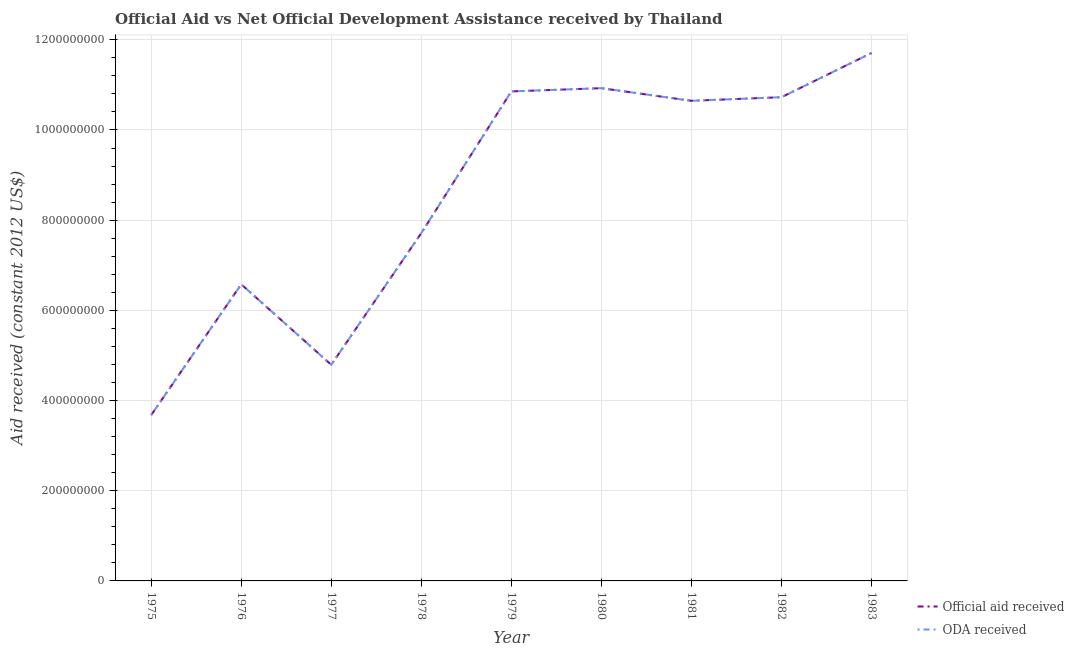Does the line corresponding to official aid received intersect with the line corresponding to oda received?
Provide a succinct answer. Yes. Is the number of lines equal to the number of legend labels?
Provide a succinct answer. Yes. What is the official aid received in 1975?
Offer a very short reply. 3.68e+08. Across all years, what is the maximum official aid received?
Your answer should be very brief. 1.17e+09. Across all years, what is the minimum official aid received?
Your answer should be compact. 3.68e+08. In which year was the official aid received minimum?
Give a very brief answer. 1975. What is the total oda received in the graph?
Provide a succinct answer. 7.76e+09. What is the difference between the official aid received in 1976 and that in 1983?
Your answer should be compact. -5.13e+08. What is the difference between the official aid received in 1975 and the oda received in 1983?
Provide a short and direct response. -8.03e+08. What is the average oda received per year?
Your answer should be compact. 8.63e+08. What is the ratio of the oda received in 1981 to that in 1982?
Offer a very short reply. 0.99. What is the difference between the highest and the second highest official aid received?
Your answer should be compact. 7.81e+07. What is the difference between the highest and the lowest official aid received?
Offer a terse response. 8.03e+08. In how many years, is the oda received greater than the average oda received taken over all years?
Your response must be concise. 5. Does the official aid received monotonically increase over the years?
Provide a short and direct response. No. Is the official aid received strictly less than the oda received over the years?
Make the answer very short. No. How many lines are there?
Provide a short and direct response. 2. How many legend labels are there?
Your answer should be very brief. 2. What is the title of the graph?
Keep it short and to the point. Official Aid vs Net Official Development Assistance received by Thailand . Does "Non-residents" appear as one of the legend labels in the graph?
Your response must be concise. No. What is the label or title of the Y-axis?
Provide a short and direct response. Aid received (constant 2012 US$). What is the Aid received (constant 2012 US$) in Official aid received in 1975?
Make the answer very short. 3.68e+08. What is the Aid received (constant 2012 US$) in ODA received in 1975?
Provide a short and direct response. 3.68e+08. What is the Aid received (constant 2012 US$) in Official aid received in 1976?
Provide a succinct answer. 6.58e+08. What is the Aid received (constant 2012 US$) in ODA received in 1976?
Provide a succinct answer. 6.58e+08. What is the Aid received (constant 2012 US$) in Official aid received in 1977?
Offer a terse response. 4.79e+08. What is the Aid received (constant 2012 US$) in ODA received in 1977?
Your response must be concise. 4.79e+08. What is the Aid received (constant 2012 US$) in Official aid received in 1978?
Your response must be concise. 7.71e+08. What is the Aid received (constant 2012 US$) in ODA received in 1978?
Offer a terse response. 7.71e+08. What is the Aid received (constant 2012 US$) in Official aid received in 1979?
Keep it short and to the point. 1.09e+09. What is the Aid received (constant 2012 US$) in ODA received in 1979?
Keep it short and to the point. 1.09e+09. What is the Aid received (constant 2012 US$) in Official aid received in 1980?
Make the answer very short. 1.09e+09. What is the Aid received (constant 2012 US$) in ODA received in 1980?
Your answer should be very brief. 1.09e+09. What is the Aid received (constant 2012 US$) in Official aid received in 1981?
Offer a terse response. 1.06e+09. What is the Aid received (constant 2012 US$) in ODA received in 1981?
Provide a succinct answer. 1.06e+09. What is the Aid received (constant 2012 US$) of Official aid received in 1982?
Your answer should be compact. 1.07e+09. What is the Aid received (constant 2012 US$) in ODA received in 1982?
Offer a terse response. 1.07e+09. What is the Aid received (constant 2012 US$) in Official aid received in 1983?
Give a very brief answer. 1.17e+09. What is the Aid received (constant 2012 US$) in ODA received in 1983?
Offer a very short reply. 1.17e+09. Across all years, what is the maximum Aid received (constant 2012 US$) in Official aid received?
Your answer should be compact. 1.17e+09. Across all years, what is the maximum Aid received (constant 2012 US$) in ODA received?
Your answer should be compact. 1.17e+09. Across all years, what is the minimum Aid received (constant 2012 US$) in Official aid received?
Provide a short and direct response. 3.68e+08. Across all years, what is the minimum Aid received (constant 2012 US$) of ODA received?
Keep it short and to the point. 3.68e+08. What is the total Aid received (constant 2012 US$) in Official aid received in the graph?
Provide a short and direct response. 7.76e+09. What is the total Aid received (constant 2012 US$) of ODA received in the graph?
Ensure brevity in your answer.  7.76e+09. What is the difference between the Aid received (constant 2012 US$) of Official aid received in 1975 and that in 1976?
Ensure brevity in your answer.  -2.90e+08. What is the difference between the Aid received (constant 2012 US$) of ODA received in 1975 and that in 1976?
Offer a terse response. -2.90e+08. What is the difference between the Aid received (constant 2012 US$) of Official aid received in 1975 and that in 1977?
Your response must be concise. -1.12e+08. What is the difference between the Aid received (constant 2012 US$) of ODA received in 1975 and that in 1977?
Offer a very short reply. -1.12e+08. What is the difference between the Aid received (constant 2012 US$) in Official aid received in 1975 and that in 1978?
Offer a terse response. -4.04e+08. What is the difference between the Aid received (constant 2012 US$) of ODA received in 1975 and that in 1978?
Ensure brevity in your answer.  -4.04e+08. What is the difference between the Aid received (constant 2012 US$) in Official aid received in 1975 and that in 1979?
Offer a very short reply. -7.18e+08. What is the difference between the Aid received (constant 2012 US$) of ODA received in 1975 and that in 1979?
Make the answer very short. -7.18e+08. What is the difference between the Aid received (constant 2012 US$) in Official aid received in 1975 and that in 1980?
Your answer should be very brief. -7.25e+08. What is the difference between the Aid received (constant 2012 US$) of ODA received in 1975 and that in 1980?
Provide a succinct answer. -7.25e+08. What is the difference between the Aid received (constant 2012 US$) in Official aid received in 1975 and that in 1981?
Offer a very short reply. -6.97e+08. What is the difference between the Aid received (constant 2012 US$) of ODA received in 1975 and that in 1981?
Keep it short and to the point. -6.97e+08. What is the difference between the Aid received (constant 2012 US$) of Official aid received in 1975 and that in 1982?
Offer a very short reply. -7.05e+08. What is the difference between the Aid received (constant 2012 US$) of ODA received in 1975 and that in 1982?
Your answer should be compact. -7.05e+08. What is the difference between the Aid received (constant 2012 US$) of Official aid received in 1975 and that in 1983?
Offer a very short reply. -8.03e+08. What is the difference between the Aid received (constant 2012 US$) in ODA received in 1975 and that in 1983?
Give a very brief answer. -8.03e+08. What is the difference between the Aid received (constant 2012 US$) of Official aid received in 1976 and that in 1977?
Make the answer very short. 1.79e+08. What is the difference between the Aid received (constant 2012 US$) in ODA received in 1976 and that in 1977?
Provide a succinct answer. 1.79e+08. What is the difference between the Aid received (constant 2012 US$) in Official aid received in 1976 and that in 1978?
Give a very brief answer. -1.14e+08. What is the difference between the Aid received (constant 2012 US$) in ODA received in 1976 and that in 1978?
Ensure brevity in your answer.  -1.14e+08. What is the difference between the Aid received (constant 2012 US$) of Official aid received in 1976 and that in 1979?
Offer a very short reply. -4.28e+08. What is the difference between the Aid received (constant 2012 US$) of ODA received in 1976 and that in 1979?
Your answer should be compact. -4.28e+08. What is the difference between the Aid received (constant 2012 US$) in Official aid received in 1976 and that in 1980?
Give a very brief answer. -4.35e+08. What is the difference between the Aid received (constant 2012 US$) in ODA received in 1976 and that in 1980?
Keep it short and to the point. -4.35e+08. What is the difference between the Aid received (constant 2012 US$) in Official aid received in 1976 and that in 1981?
Your answer should be compact. -4.07e+08. What is the difference between the Aid received (constant 2012 US$) of ODA received in 1976 and that in 1981?
Keep it short and to the point. -4.07e+08. What is the difference between the Aid received (constant 2012 US$) in Official aid received in 1976 and that in 1982?
Offer a terse response. -4.15e+08. What is the difference between the Aid received (constant 2012 US$) in ODA received in 1976 and that in 1982?
Your answer should be very brief. -4.15e+08. What is the difference between the Aid received (constant 2012 US$) in Official aid received in 1976 and that in 1983?
Offer a terse response. -5.13e+08. What is the difference between the Aid received (constant 2012 US$) of ODA received in 1976 and that in 1983?
Provide a short and direct response. -5.13e+08. What is the difference between the Aid received (constant 2012 US$) of Official aid received in 1977 and that in 1978?
Give a very brief answer. -2.92e+08. What is the difference between the Aid received (constant 2012 US$) in ODA received in 1977 and that in 1978?
Offer a very short reply. -2.92e+08. What is the difference between the Aid received (constant 2012 US$) in Official aid received in 1977 and that in 1979?
Offer a very short reply. -6.06e+08. What is the difference between the Aid received (constant 2012 US$) in ODA received in 1977 and that in 1979?
Your response must be concise. -6.06e+08. What is the difference between the Aid received (constant 2012 US$) of Official aid received in 1977 and that in 1980?
Your response must be concise. -6.13e+08. What is the difference between the Aid received (constant 2012 US$) of ODA received in 1977 and that in 1980?
Provide a succinct answer. -6.13e+08. What is the difference between the Aid received (constant 2012 US$) in Official aid received in 1977 and that in 1981?
Your answer should be compact. -5.85e+08. What is the difference between the Aid received (constant 2012 US$) of ODA received in 1977 and that in 1981?
Offer a very short reply. -5.85e+08. What is the difference between the Aid received (constant 2012 US$) in Official aid received in 1977 and that in 1982?
Ensure brevity in your answer.  -5.93e+08. What is the difference between the Aid received (constant 2012 US$) of ODA received in 1977 and that in 1982?
Make the answer very short. -5.93e+08. What is the difference between the Aid received (constant 2012 US$) of Official aid received in 1977 and that in 1983?
Keep it short and to the point. -6.91e+08. What is the difference between the Aid received (constant 2012 US$) of ODA received in 1977 and that in 1983?
Your answer should be compact. -6.91e+08. What is the difference between the Aid received (constant 2012 US$) in Official aid received in 1978 and that in 1979?
Your answer should be very brief. -3.14e+08. What is the difference between the Aid received (constant 2012 US$) of ODA received in 1978 and that in 1979?
Keep it short and to the point. -3.14e+08. What is the difference between the Aid received (constant 2012 US$) of Official aid received in 1978 and that in 1980?
Provide a short and direct response. -3.21e+08. What is the difference between the Aid received (constant 2012 US$) in ODA received in 1978 and that in 1980?
Give a very brief answer. -3.21e+08. What is the difference between the Aid received (constant 2012 US$) in Official aid received in 1978 and that in 1981?
Offer a terse response. -2.93e+08. What is the difference between the Aid received (constant 2012 US$) of ODA received in 1978 and that in 1981?
Keep it short and to the point. -2.93e+08. What is the difference between the Aid received (constant 2012 US$) of Official aid received in 1978 and that in 1982?
Provide a succinct answer. -3.01e+08. What is the difference between the Aid received (constant 2012 US$) in ODA received in 1978 and that in 1982?
Offer a terse response. -3.01e+08. What is the difference between the Aid received (constant 2012 US$) in Official aid received in 1978 and that in 1983?
Give a very brief answer. -3.99e+08. What is the difference between the Aid received (constant 2012 US$) of ODA received in 1978 and that in 1983?
Give a very brief answer. -3.99e+08. What is the difference between the Aid received (constant 2012 US$) of Official aid received in 1979 and that in 1980?
Your answer should be compact. -7.12e+06. What is the difference between the Aid received (constant 2012 US$) in ODA received in 1979 and that in 1980?
Your response must be concise. -7.12e+06. What is the difference between the Aid received (constant 2012 US$) in Official aid received in 1979 and that in 1981?
Your answer should be compact. 2.09e+07. What is the difference between the Aid received (constant 2012 US$) in ODA received in 1979 and that in 1981?
Your answer should be compact. 2.09e+07. What is the difference between the Aid received (constant 2012 US$) of Official aid received in 1979 and that in 1982?
Provide a short and direct response. 1.29e+07. What is the difference between the Aid received (constant 2012 US$) in ODA received in 1979 and that in 1982?
Provide a short and direct response. 1.29e+07. What is the difference between the Aid received (constant 2012 US$) in Official aid received in 1979 and that in 1983?
Keep it short and to the point. -8.52e+07. What is the difference between the Aid received (constant 2012 US$) in ODA received in 1979 and that in 1983?
Your response must be concise. -8.52e+07. What is the difference between the Aid received (constant 2012 US$) of Official aid received in 1980 and that in 1981?
Provide a succinct answer. 2.80e+07. What is the difference between the Aid received (constant 2012 US$) of ODA received in 1980 and that in 1981?
Offer a very short reply. 2.80e+07. What is the difference between the Aid received (constant 2012 US$) of Official aid received in 1980 and that in 1982?
Keep it short and to the point. 2.00e+07. What is the difference between the Aid received (constant 2012 US$) of ODA received in 1980 and that in 1982?
Your answer should be very brief. 2.00e+07. What is the difference between the Aid received (constant 2012 US$) of Official aid received in 1980 and that in 1983?
Ensure brevity in your answer.  -7.81e+07. What is the difference between the Aid received (constant 2012 US$) in ODA received in 1980 and that in 1983?
Ensure brevity in your answer.  -7.81e+07. What is the difference between the Aid received (constant 2012 US$) in Official aid received in 1981 and that in 1982?
Ensure brevity in your answer.  -8.00e+06. What is the difference between the Aid received (constant 2012 US$) of ODA received in 1981 and that in 1982?
Keep it short and to the point. -8.00e+06. What is the difference between the Aid received (constant 2012 US$) of Official aid received in 1981 and that in 1983?
Ensure brevity in your answer.  -1.06e+08. What is the difference between the Aid received (constant 2012 US$) of ODA received in 1981 and that in 1983?
Ensure brevity in your answer.  -1.06e+08. What is the difference between the Aid received (constant 2012 US$) of Official aid received in 1982 and that in 1983?
Your answer should be very brief. -9.80e+07. What is the difference between the Aid received (constant 2012 US$) in ODA received in 1982 and that in 1983?
Your answer should be very brief. -9.80e+07. What is the difference between the Aid received (constant 2012 US$) of Official aid received in 1975 and the Aid received (constant 2012 US$) of ODA received in 1976?
Your answer should be very brief. -2.90e+08. What is the difference between the Aid received (constant 2012 US$) of Official aid received in 1975 and the Aid received (constant 2012 US$) of ODA received in 1977?
Give a very brief answer. -1.12e+08. What is the difference between the Aid received (constant 2012 US$) in Official aid received in 1975 and the Aid received (constant 2012 US$) in ODA received in 1978?
Make the answer very short. -4.04e+08. What is the difference between the Aid received (constant 2012 US$) in Official aid received in 1975 and the Aid received (constant 2012 US$) in ODA received in 1979?
Your answer should be compact. -7.18e+08. What is the difference between the Aid received (constant 2012 US$) of Official aid received in 1975 and the Aid received (constant 2012 US$) of ODA received in 1980?
Ensure brevity in your answer.  -7.25e+08. What is the difference between the Aid received (constant 2012 US$) of Official aid received in 1975 and the Aid received (constant 2012 US$) of ODA received in 1981?
Provide a short and direct response. -6.97e+08. What is the difference between the Aid received (constant 2012 US$) of Official aid received in 1975 and the Aid received (constant 2012 US$) of ODA received in 1982?
Provide a short and direct response. -7.05e+08. What is the difference between the Aid received (constant 2012 US$) of Official aid received in 1975 and the Aid received (constant 2012 US$) of ODA received in 1983?
Your response must be concise. -8.03e+08. What is the difference between the Aid received (constant 2012 US$) in Official aid received in 1976 and the Aid received (constant 2012 US$) in ODA received in 1977?
Your answer should be very brief. 1.79e+08. What is the difference between the Aid received (constant 2012 US$) in Official aid received in 1976 and the Aid received (constant 2012 US$) in ODA received in 1978?
Give a very brief answer. -1.14e+08. What is the difference between the Aid received (constant 2012 US$) in Official aid received in 1976 and the Aid received (constant 2012 US$) in ODA received in 1979?
Offer a very short reply. -4.28e+08. What is the difference between the Aid received (constant 2012 US$) in Official aid received in 1976 and the Aid received (constant 2012 US$) in ODA received in 1980?
Give a very brief answer. -4.35e+08. What is the difference between the Aid received (constant 2012 US$) in Official aid received in 1976 and the Aid received (constant 2012 US$) in ODA received in 1981?
Your answer should be very brief. -4.07e+08. What is the difference between the Aid received (constant 2012 US$) in Official aid received in 1976 and the Aid received (constant 2012 US$) in ODA received in 1982?
Your answer should be very brief. -4.15e+08. What is the difference between the Aid received (constant 2012 US$) of Official aid received in 1976 and the Aid received (constant 2012 US$) of ODA received in 1983?
Keep it short and to the point. -5.13e+08. What is the difference between the Aid received (constant 2012 US$) of Official aid received in 1977 and the Aid received (constant 2012 US$) of ODA received in 1978?
Ensure brevity in your answer.  -2.92e+08. What is the difference between the Aid received (constant 2012 US$) in Official aid received in 1977 and the Aid received (constant 2012 US$) in ODA received in 1979?
Your response must be concise. -6.06e+08. What is the difference between the Aid received (constant 2012 US$) in Official aid received in 1977 and the Aid received (constant 2012 US$) in ODA received in 1980?
Ensure brevity in your answer.  -6.13e+08. What is the difference between the Aid received (constant 2012 US$) in Official aid received in 1977 and the Aid received (constant 2012 US$) in ODA received in 1981?
Make the answer very short. -5.85e+08. What is the difference between the Aid received (constant 2012 US$) of Official aid received in 1977 and the Aid received (constant 2012 US$) of ODA received in 1982?
Your answer should be compact. -5.93e+08. What is the difference between the Aid received (constant 2012 US$) in Official aid received in 1977 and the Aid received (constant 2012 US$) in ODA received in 1983?
Provide a short and direct response. -6.91e+08. What is the difference between the Aid received (constant 2012 US$) of Official aid received in 1978 and the Aid received (constant 2012 US$) of ODA received in 1979?
Give a very brief answer. -3.14e+08. What is the difference between the Aid received (constant 2012 US$) in Official aid received in 1978 and the Aid received (constant 2012 US$) in ODA received in 1980?
Provide a short and direct response. -3.21e+08. What is the difference between the Aid received (constant 2012 US$) of Official aid received in 1978 and the Aid received (constant 2012 US$) of ODA received in 1981?
Your answer should be compact. -2.93e+08. What is the difference between the Aid received (constant 2012 US$) in Official aid received in 1978 and the Aid received (constant 2012 US$) in ODA received in 1982?
Offer a terse response. -3.01e+08. What is the difference between the Aid received (constant 2012 US$) in Official aid received in 1978 and the Aid received (constant 2012 US$) in ODA received in 1983?
Your response must be concise. -3.99e+08. What is the difference between the Aid received (constant 2012 US$) of Official aid received in 1979 and the Aid received (constant 2012 US$) of ODA received in 1980?
Your answer should be very brief. -7.12e+06. What is the difference between the Aid received (constant 2012 US$) of Official aid received in 1979 and the Aid received (constant 2012 US$) of ODA received in 1981?
Your response must be concise. 2.09e+07. What is the difference between the Aid received (constant 2012 US$) in Official aid received in 1979 and the Aid received (constant 2012 US$) in ODA received in 1982?
Provide a succinct answer. 1.29e+07. What is the difference between the Aid received (constant 2012 US$) of Official aid received in 1979 and the Aid received (constant 2012 US$) of ODA received in 1983?
Offer a terse response. -8.52e+07. What is the difference between the Aid received (constant 2012 US$) in Official aid received in 1980 and the Aid received (constant 2012 US$) in ODA received in 1981?
Ensure brevity in your answer.  2.80e+07. What is the difference between the Aid received (constant 2012 US$) of Official aid received in 1980 and the Aid received (constant 2012 US$) of ODA received in 1982?
Offer a very short reply. 2.00e+07. What is the difference between the Aid received (constant 2012 US$) in Official aid received in 1980 and the Aid received (constant 2012 US$) in ODA received in 1983?
Provide a short and direct response. -7.81e+07. What is the difference between the Aid received (constant 2012 US$) in Official aid received in 1981 and the Aid received (constant 2012 US$) in ODA received in 1982?
Ensure brevity in your answer.  -8.00e+06. What is the difference between the Aid received (constant 2012 US$) of Official aid received in 1981 and the Aid received (constant 2012 US$) of ODA received in 1983?
Your answer should be very brief. -1.06e+08. What is the difference between the Aid received (constant 2012 US$) of Official aid received in 1982 and the Aid received (constant 2012 US$) of ODA received in 1983?
Offer a terse response. -9.80e+07. What is the average Aid received (constant 2012 US$) in Official aid received per year?
Your answer should be very brief. 8.63e+08. What is the average Aid received (constant 2012 US$) of ODA received per year?
Offer a very short reply. 8.63e+08. In the year 1975, what is the difference between the Aid received (constant 2012 US$) of Official aid received and Aid received (constant 2012 US$) of ODA received?
Offer a terse response. 0. In the year 1976, what is the difference between the Aid received (constant 2012 US$) in Official aid received and Aid received (constant 2012 US$) in ODA received?
Give a very brief answer. 0. In the year 1977, what is the difference between the Aid received (constant 2012 US$) of Official aid received and Aid received (constant 2012 US$) of ODA received?
Offer a very short reply. 0. In the year 1982, what is the difference between the Aid received (constant 2012 US$) of Official aid received and Aid received (constant 2012 US$) of ODA received?
Make the answer very short. 0. In the year 1983, what is the difference between the Aid received (constant 2012 US$) of Official aid received and Aid received (constant 2012 US$) of ODA received?
Make the answer very short. 0. What is the ratio of the Aid received (constant 2012 US$) in Official aid received in 1975 to that in 1976?
Give a very brief answer. 0.56. What is the ratio of the Aid received (constant 2012 US$) of ODA received in 1975 to that in 1976?
Give a very brief answer. 0.56. What is the ratio of the Aid received (constant 2012 US$) in Official aid received in 1975 to that in 1977?
Offer a terse response. 0.77. What is the ratio of the Aid received (constant 2012 US$) in ODA received in 1975 to that in 1977?
Make the answer very short. 0.77. What is the ratio of the Aid received (constant 2012 US$) of Official aid received in 1975 to that in 1978?
Make the answer very short. 0.48. What is the ratio of the Aid received (constant 2012 US$) of ODA received in 1975 to that in 1978?
Offer a very short reply. 0.48. What is the ratio of the Aid received (constant 2012 US$) in Official aid received in 1975 to that in 1979?
Give a very brief answer. 0.34. What is the ratio of the Aid received (constant 2012 US$) of ODA received in 1975 to that in 1979?
Offer a terse response. 0.34. What is the ratio of the Aid received (constant 2012 US$) of Official aid received in 1975 to that in 1980?
Your answer should be compact. 0.34. What is the ratio of the Aid received (constant 2012 US$) of ODA received in 1975 to that in 1980?
Your answer should be compact. 0.34. What is the ratio of the Aid received (constant 2012 US$) of Official aid received in 1975 to that in 1981?
Provide a short and direct response. 0.35. What is the ratio of the Aid received (constant 2012 US$) of ODA received in 1975 to that in 1981?
Provide a short and direct response. 0.35. What is the ratio of the Aid received (constant 2012 US$) in Official aid received in 1975 to that in 1982?
Provide a short and direct response. 0.34. What is the ratio of the Aid received (constant 2012 US$) of ODA received in 1975 to that in 1982?
Your answer should be very brief. 0.34. What is the ratio of the Aid received (constant 2012 US$) of Official aid received in 1975 to that in 1983?
Provide a short and direct response. 0.31. What is the ratio of the Aid received (constant 2012 US$) in ODA received in 1975 to that in 1983?
Provide a succinct answer. 0.31. What is the ratio of the Aid received (constant 2012 US$) in Official aid received in 1976 to that in 1977?
Your answer should be compact. 1.37. What is the ratio of the Aid received (constant 2012 US$) in ODA received in 1976 to that in 1977?
Keep it short and to the point. 1.37. What is the ratio of the Aid received (constant 2012 US$) in Official aid received in 1976 to that in 1978?
Your response must be concise. 0.85. What is the ratio of the Aid received (constant 2012 US$) in ODA received in 1976 to that in 1978?
Your response must be concise. 0.85. What is the ratio of the Aid received (constant 2012 US$) in Official aid received in 1976 to that in 1979?
Give a very brief answer. 0.61. What is the ratio of the Aid received (constant 2012 US$) in ODA received in 1976 to that in 1979?
Your answer should be very brief. 0.61. What is the ratio of the Aid received (constant 2012 US$) of Official aid received in 1976 to that in 1980?
Give a very brief answer. 0.6. What is the ratio of the Aid received (constant 2012 US$) of ODA received in 1976 to that in 1980?
Your answer should be very brief. 0.6. What is the ratio of the Aid received (constant 2012 US$) in Official aid received in 1976 to that in 1981?
Your response must be concise. 0.62. What is the ratio of the Aid received (constant 2012 US$) of ODA received in 1976 to that in 1981?
Offer a terse response. 0.62. What is the ratio of the Aid received (constant 2012 US$) in Official aid received in 1976 to that in 1982?
Offer a terse response. 0.61. What is the ratio of the Aid received (constant 2012 US$) in ODA received in 1976 to that in 1982?
Provide a short and direct response. 0.61. What is the ratio of the Aid received (constant 2012 US$) in Official aid received in 1976 to that in 1983?
Keep it short and to the point. 0.56. What is the ratio of the Aid received (constant 2012 US$) in ODA received in 1976 to that in 1983?
Your answer should be very brief. 0.56. What is the ratio of the Aid received (constant 2012 US$) of Official aid received in 1977 to that in 1978?
Provide a succinct answer. 0.62. What is the ratio of the Aid received (constant 2012 US$) in ODA received in 1977 to that in 1978?
Provide a succinct answer. 0.62. What is the ratio of the Aid received (constant 2012 US$) of Official aid received in 1977 to that in 1979?
Provide a short and direct response. 0.44. What is the ratio of the Aid received (constant 2012 US$) in ODA received in 1977 to that in 1979?
Give a very brief answer. 0.44. What is the ratio of the Aid received (constant 2012 US$) of Official aid received in 1977 to that in 1980?
Provide a succinct answer. 0.44. What is the ratio of the Aid received (constant 2012 US$) in ODA received in 1977 to that in 1980?
Your answer should be compact. 0.44. What is the ratio of the Aid received (constant 2012 US$) in Official aid received in 1977 to that in 1981?
Your answer should be compact. 0.45. What is the ratio of the Aid received (constant 2012 US$) of ODA received in 1977 to that in 1981?
Your answer should be very brief. 0.45. What is the ratio of the Aid received (constant 2012 US$) of Official aid received in 1977 to that in 1982?
Your response must be concise. 0.45. What is the ratio of the Aid received (constant 2012 US$) in ODA received in 1977 to that in 1982?
Your answer should be compact. 0.45. What is the ratio of the Aid received (constant 2012 US$) in Official aid received in 1977 to that in 1983?
Give a very brief answer. 0.41. What is the ratio of the Aid received (constant 2012 US$) of ODA received in 1977 to that in 1983?
Offer a very short reply. 0.41. What is the ratio of the Aid received (constant 2012 US$) in Official aid received in 1978 to that in 1979?
Offer a terse response. 0.71. What is the ratio of the Aid received (constant 2012 US$) of ODA received in 1978 to that in 1979?
Offer a terse response. 0.71. What is the ratio of the Aid received (constant 2012 US$) in Official aid received in 1978 to that in 1980?
Your response must be concise. 0.71. What is the ratio of the Aid received (constant 2012 US$) in ODA received in 1978 to that in 1980?
Provide a succinct answer. 0.71. What is the ratio of the Aid received (constant 2012 US$) in Official aid received in 1978 to that in 1981?
Your response must be concise. 0.72. What is the ratio of the Aid received (constant 2012 US$) of ODA received in 1978 to that in 1981?
Provide a short and direct response. 0.72. What is the ratio of the Aid received (constant 2012 US$) of Official aid received in 1978 to that in 1982?
Provide a succinct answer. 0.72. What is the ratio of the Aid received (constant 2012 US$) in ODA received in 1978 to that in 1982?
Provide a succinct answer. 0.72. What is the ratio of the Aid received (constant 2012 US$) in Official aid received in 1978 to that in 1983?
Provide a succinct answer. 0.66. What is the ratio of the Aid received (constant 2012 US$) in ODA received in 1978 to that in 1983?
Your answer should be compact. 0.66. What is the ratio of the Aid received (constant 2012 US$) of Official aid received in 1979 to that in 1980?
Your response must be concise. 0.99. What is the ratio of the Aid received (constant 2012 US$) of Official aid received in 1979 to that in 1981?
Give a very brief answer. 1.02. What is the ratio of the Aid received (constant 2012 US$) of ODA received in 1979 to that in 1981?
Offer a very short reply. 1.02. What is the ratio of the Aid received (constant 2012 US$) in Official aid received in 1979 to that in 1982?
Offer a terse response. 1.01. What is the ratio of the Aid received (constant 2012 US$) of Official aid received in 1979 to that in 1983?
Make the answer very short. 0.93. What is the ratio of the Aid received (constant 2012 US$) of ODA received in 1979 to that in 1983?
Your answer should be very brief. 0.93. What is the ratio of the Aid received (constant 2012 US$) in Official aid received in 1980 to that in 1981?
Your answer should be very brief. 1.03. What is the ratio of the Aid received (constant 2012 US$) in ODA received in 1980 to that in 1981?
Keep it short and to the point. 1.03. What is the ratio of the Aid received (constant 2012 US$) in Official aid received in 1980 to that in 1982?
Your response must be concise. 1.02. What is the ratio of the Aid received (constant 2012 US$) of ODA received in 1980 to that in 1982?
Your response must be concise. 1.02. What is the ratio of the Aid received (constant 2012 US$) of Official aid received in 1980 to that in 1983?
Your response must be concise. 0.93. What is the ratio of the Aid received (constant 2012 US$) of ODA received in 1981 to that in 1982?
Your answer should be compact. 0.99. What is the ratio of the Aid received (constant 2012 US$) of Official aid received in 1981 to that in 1983?
Provide a succinct answer. 0.91. What is the ratio of the Aid received (constant 2012 US$) in ODA received in 1981 to that in 1983?
Make the answer very short. 0.91. What is the ratio of the Aid received (constant 2012 US$) in Official aid received in 1982 to that in 1983?
Your answer should be very brief. 0.92. What is the ratio of the Aid received (constant 2012 US$) of ODA received in 1982 to that in 1983?
Provide a short and direct response. 0.92. What is the difference between the highest and the second highest Aid received (constant 2012 US$) of Official aid received?
Your answer should be very brief. 7.81e+07. What is the difference between the highest and the second highest Aid received (constant 2012 US$) in ODA received?
Offer a terse response. 7.81e+07. What is the difference between the highest and the lowest Aid received (constant 2012 US$) of Official aid received?
Give a very brief answer. 8.03e+08. What is the difference between the highest and the lowest Aid received (constant 2012 US$) in ODA received?
Make the answer very short. 8.03e+08. 